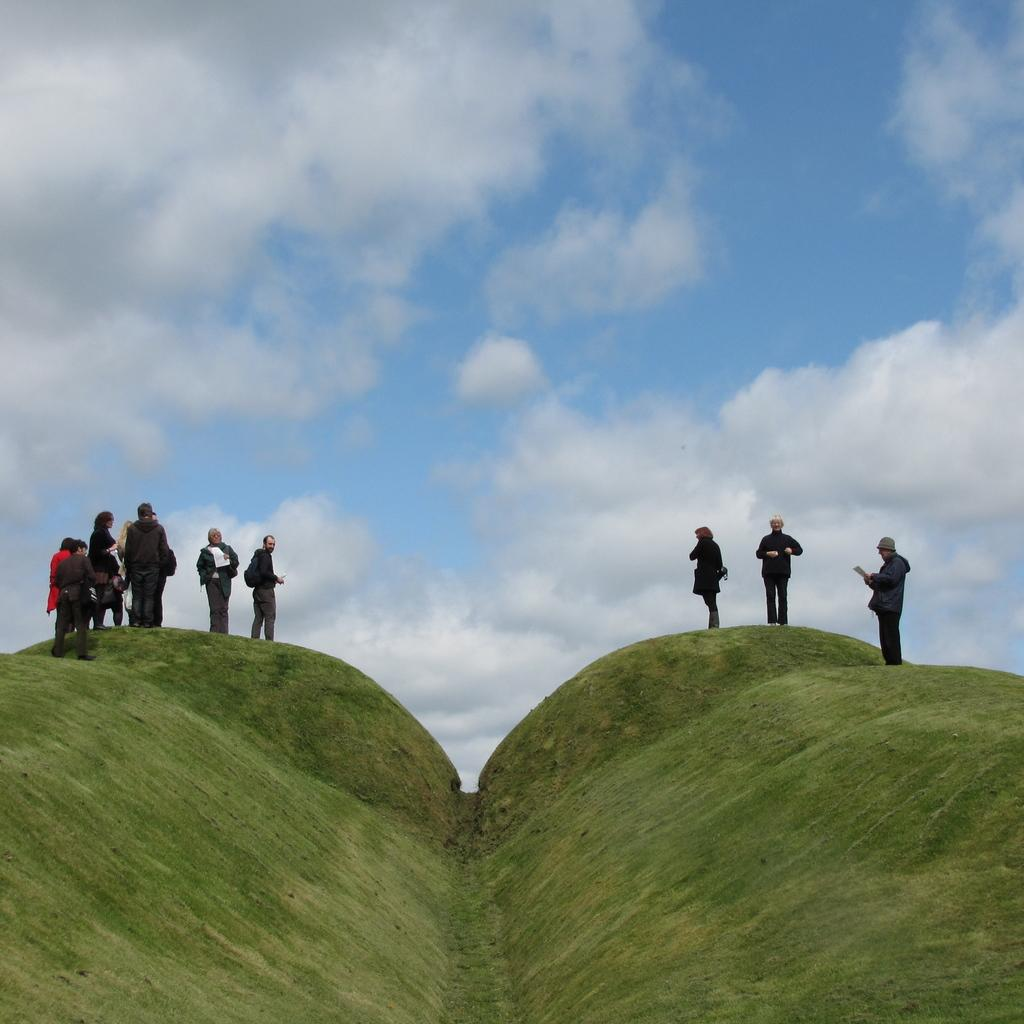What can be seen in the image? There are people standing in the image. Where are the people standing? The people are standing on green cliffs. How are the green cliffs positioned in the image? The green cliffs are in the foreground area of the image. What is visible in the background of the image? The sky is visible in the background of the image. What type of pain is being experienced by the people standing on the green cliffs in the image? There is no indication of pain being experienced by the people in the image. 